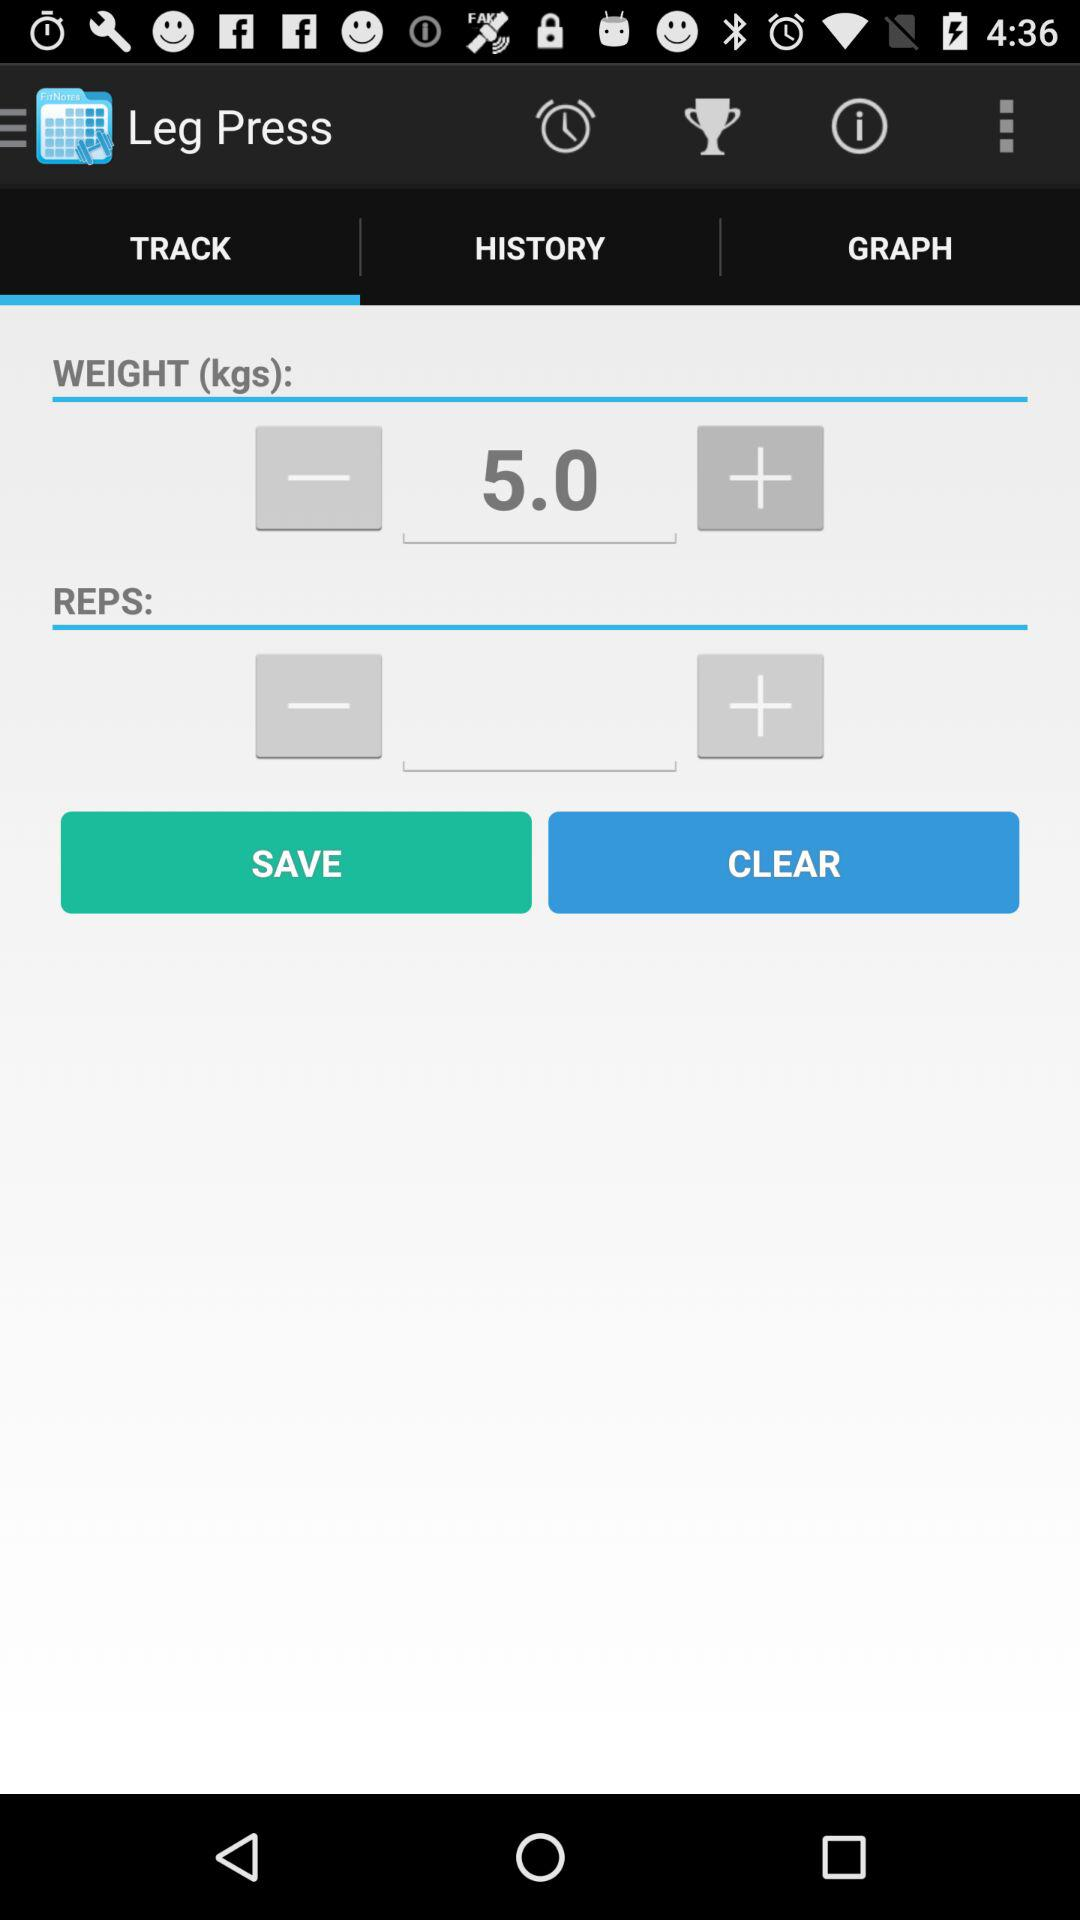Which tab is selected? The selected tab is "TRACK". 